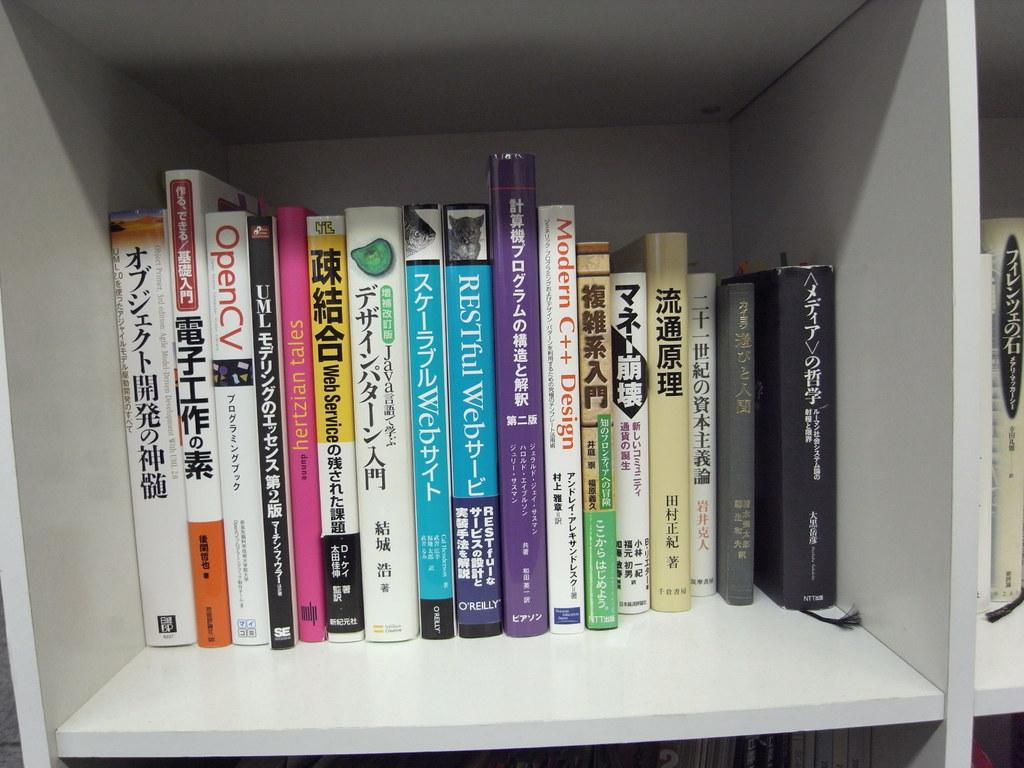<image>
Share a concise interpretation of the image provided. a shelf of bookes that has one labeled 'modern c++ design' 